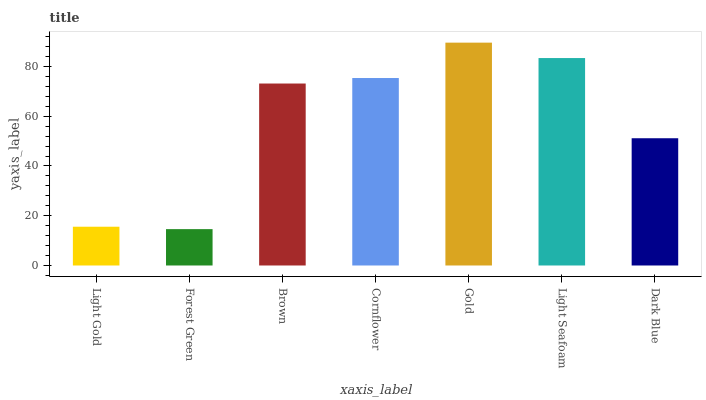Is Brown the minimum?
Answer yes or no. No. Is Brown the maximum?
Answer yes or no. No. Is Brown greater than Forest Green?
Answer yes or no. Yes. Is Forest Green less than Brown?
Answer yes or no. Yes. Is Forest Green greater than Brown?
Answer yes or no. No. Is Brown less than Forest Green?
Answer yes or no. No. Is Brown the high median?
Answer yes or no. Yes. Is Brown the low median?
Answer yes or no. Yes. Is Forest Green the high median?
Answer yes or no. No. Is Gold the low median?
Answer yes or no. No. 